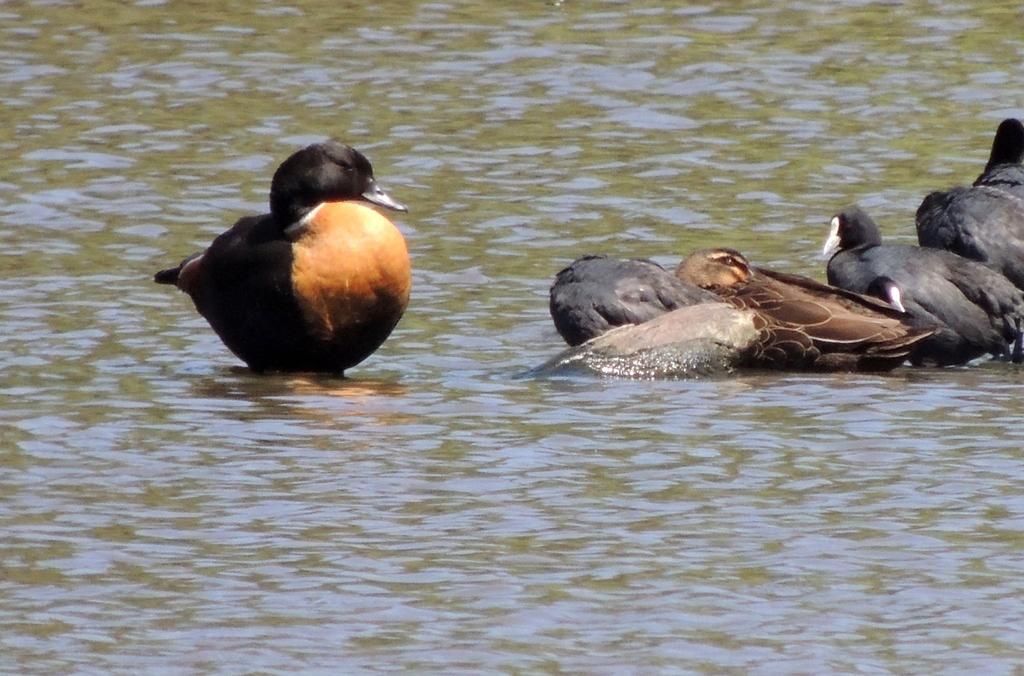Please provide a concise description of this image. In this image, we can see few birds are in the water. 